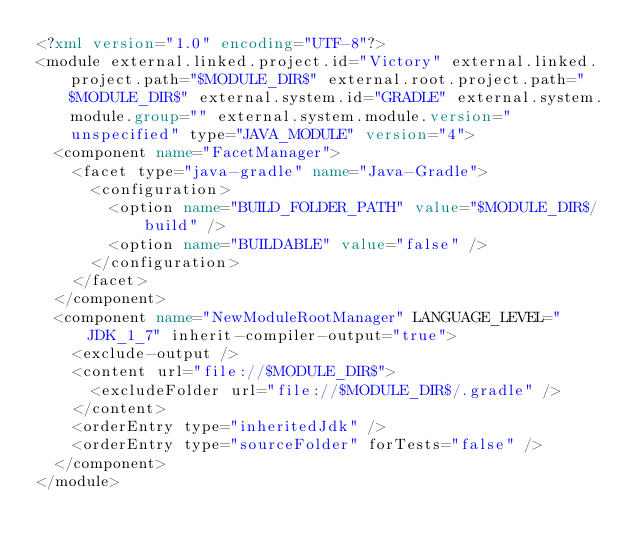<code> <loc_0><loc_0><loc_500><loc_500><_XML_><?xml version="1.0" encoding="UTF-8"?>
<module external.linked.project.id="Victory" external.linked.project.path="$MODULE_DIR$" external.root.project.path="$MODULE_DIR$" external.system.id="GRADLE" external.system.module.group="" external.system.module.version="unspecified" type="JAVA_MODULE" version="4">
  <component name="FacetManager">
    <facet type="java-gradle" name="Java-Gradle">
      <configuration>
        <option name="BUILD_FOLDER_PATH" value="$MODULE_DIR$/build" />
        <option name="BUILDABLE" value="false" />
      </configuration>
    </facet>
  </component>
  <component name="NewModuleRootManager" LANGUAGE_LEVEL="JDK_1_7" inherit-compiler-output="true">
    <exclude-output />
    <content url="file://$MODULE_DIR$">
      <excludeFolder url="file://$MODULE_DIR$/.gradle" />
    </content>
    <orderEntry type="inheritedJdk" />
    <orderEntry type="sourceFolder" forTests="false" />
  </component>
</module></code> 